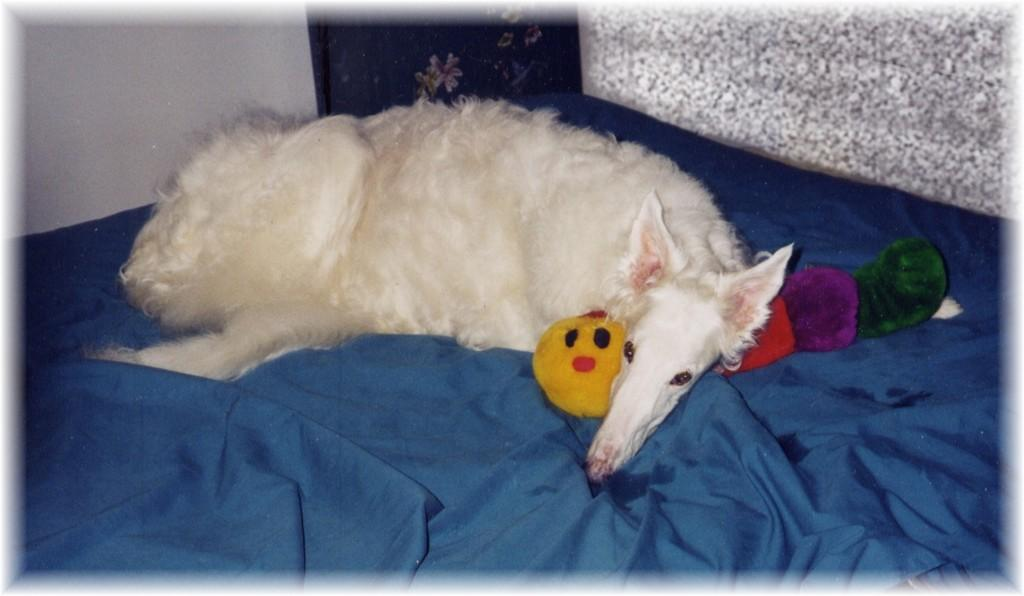What type of animal can be seen in the image? There is a dog in the image. What other object is visible in the image? There is a toy in the image. What color is the cloth present in the image? The blue cloth is present in the image. What can be seen in the background of the image? There is a wall in the background of the image. How many pies are being served by the dog in the image? There are no pies present in the image, and the dog is not serving anything. 